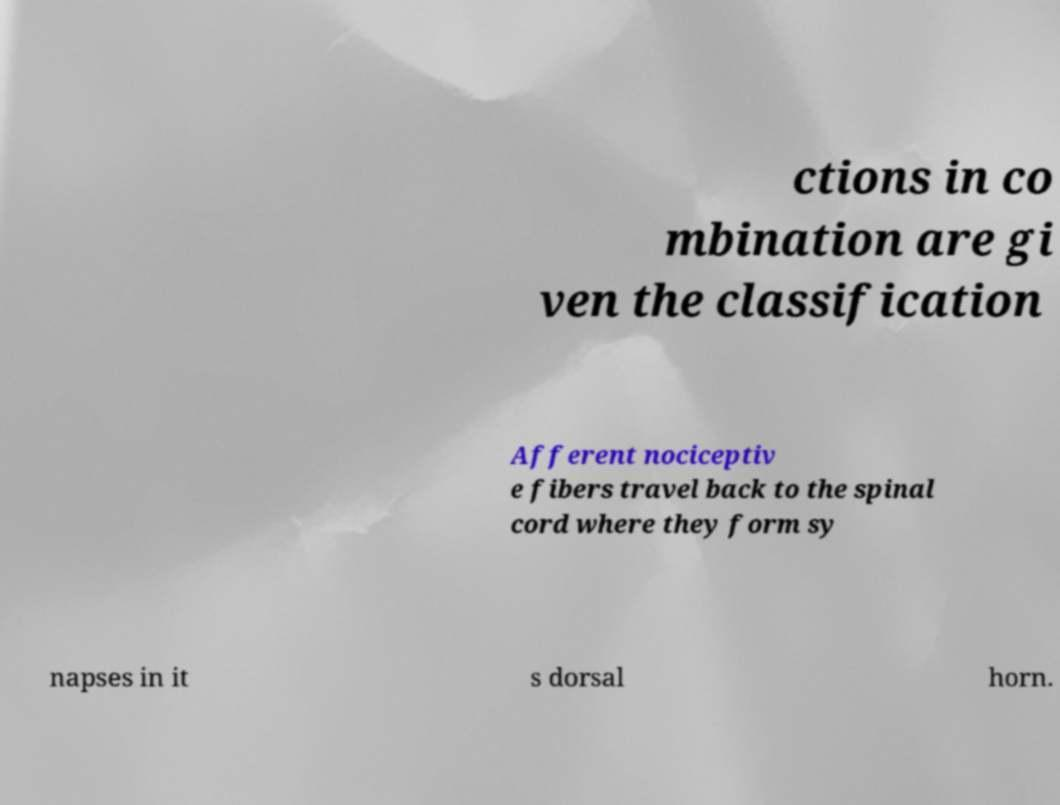What messages or text are displayed in this image? I need them in a readable, typed format. ctions in co mbination are gi ven the classification Afferent nociceptiv e fibers travel back to the spinal cord where they form sy napses in it s dorsal horn. 